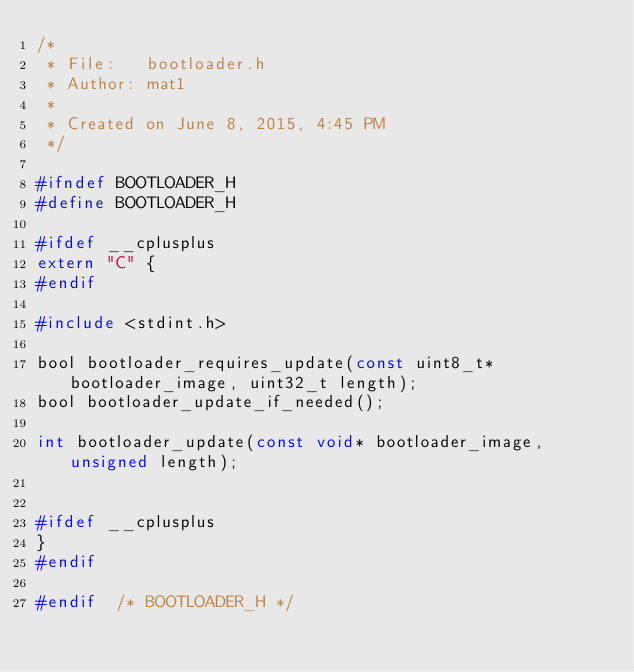<code> <loc_0><loc_0><loc_500><loc_500><_C_>/*
 * File:   bootloader.h
 * Author: mat1
 *
 * Created on June 8, 2015, 4:45 PM
 */

#ifndef BOOTLOADER_H
#define	BOOTLOADER_H

#ifdef __cplusplus
extern "C" {
#endif

#include <stdint.h>

bool bootloader_requires_update(const uint8_t* bootloader_image, uint32_t length);
bool bootloader_update_if_needed();

int bootloader_update(const void* bootloader_image, unsigned length);


#ifdef __cplusplus
}
#endif

#endif	/* BOOTLOADER_H */

</code> 